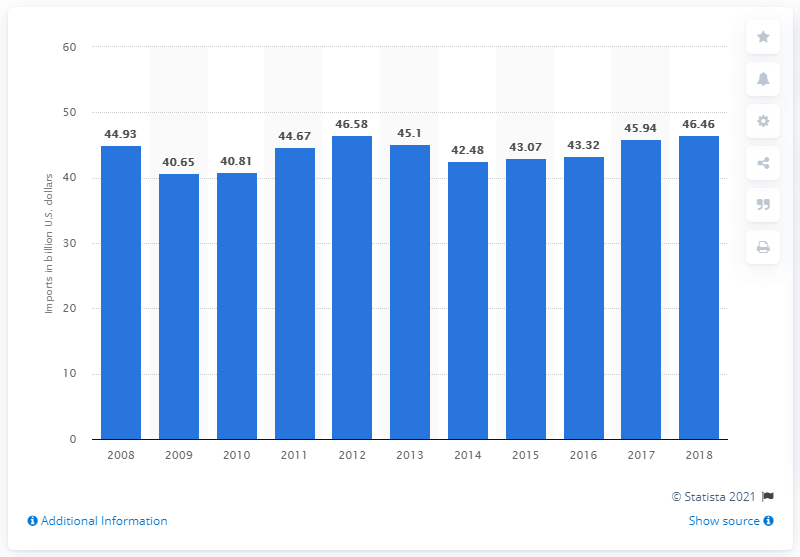Outline some significant characteristics in this image. In 2018, the value of goods and services imported to Puerto Rico was approximately $46.46 billion in U.S. dollars. 